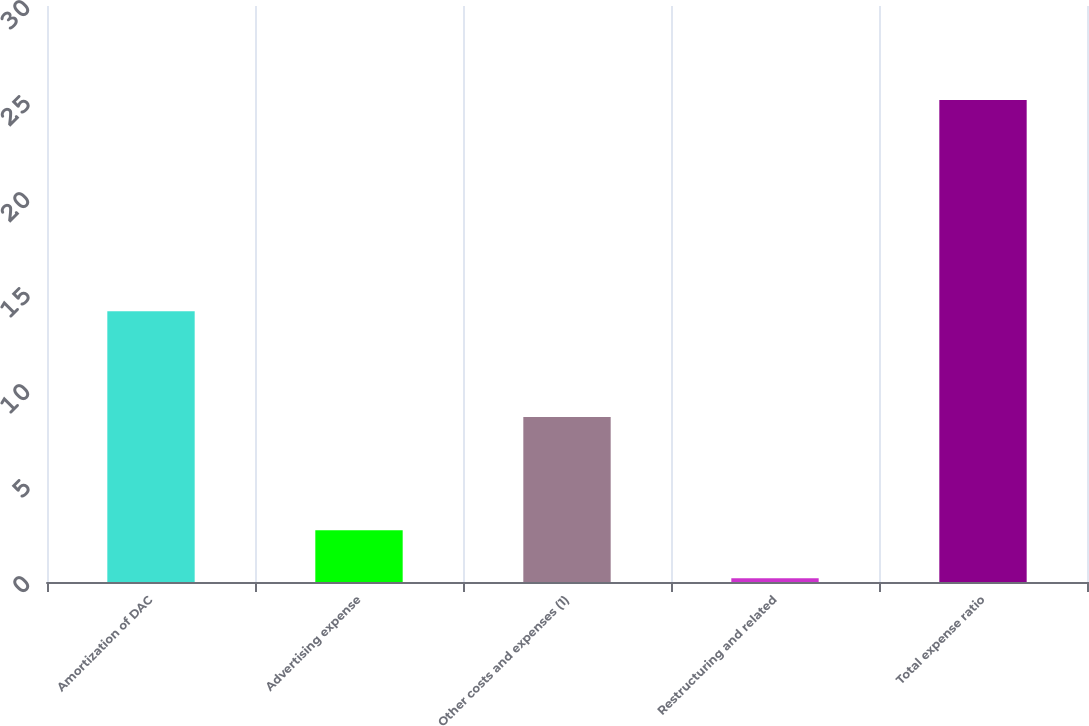<chart> <loc_0><loc_0><loc_500><loc_500><bar_chart><fcel>Amortization of DAC<fcel>Advertising expense<fcel>Other costs and expenses (1)<fcel>Restructuring and related<fcel>Total expense ratio<nl><fcel>14.1<fcel>2.69<fcel>8.6<fcel>0.2<fcel>25.1<nl></chart> 